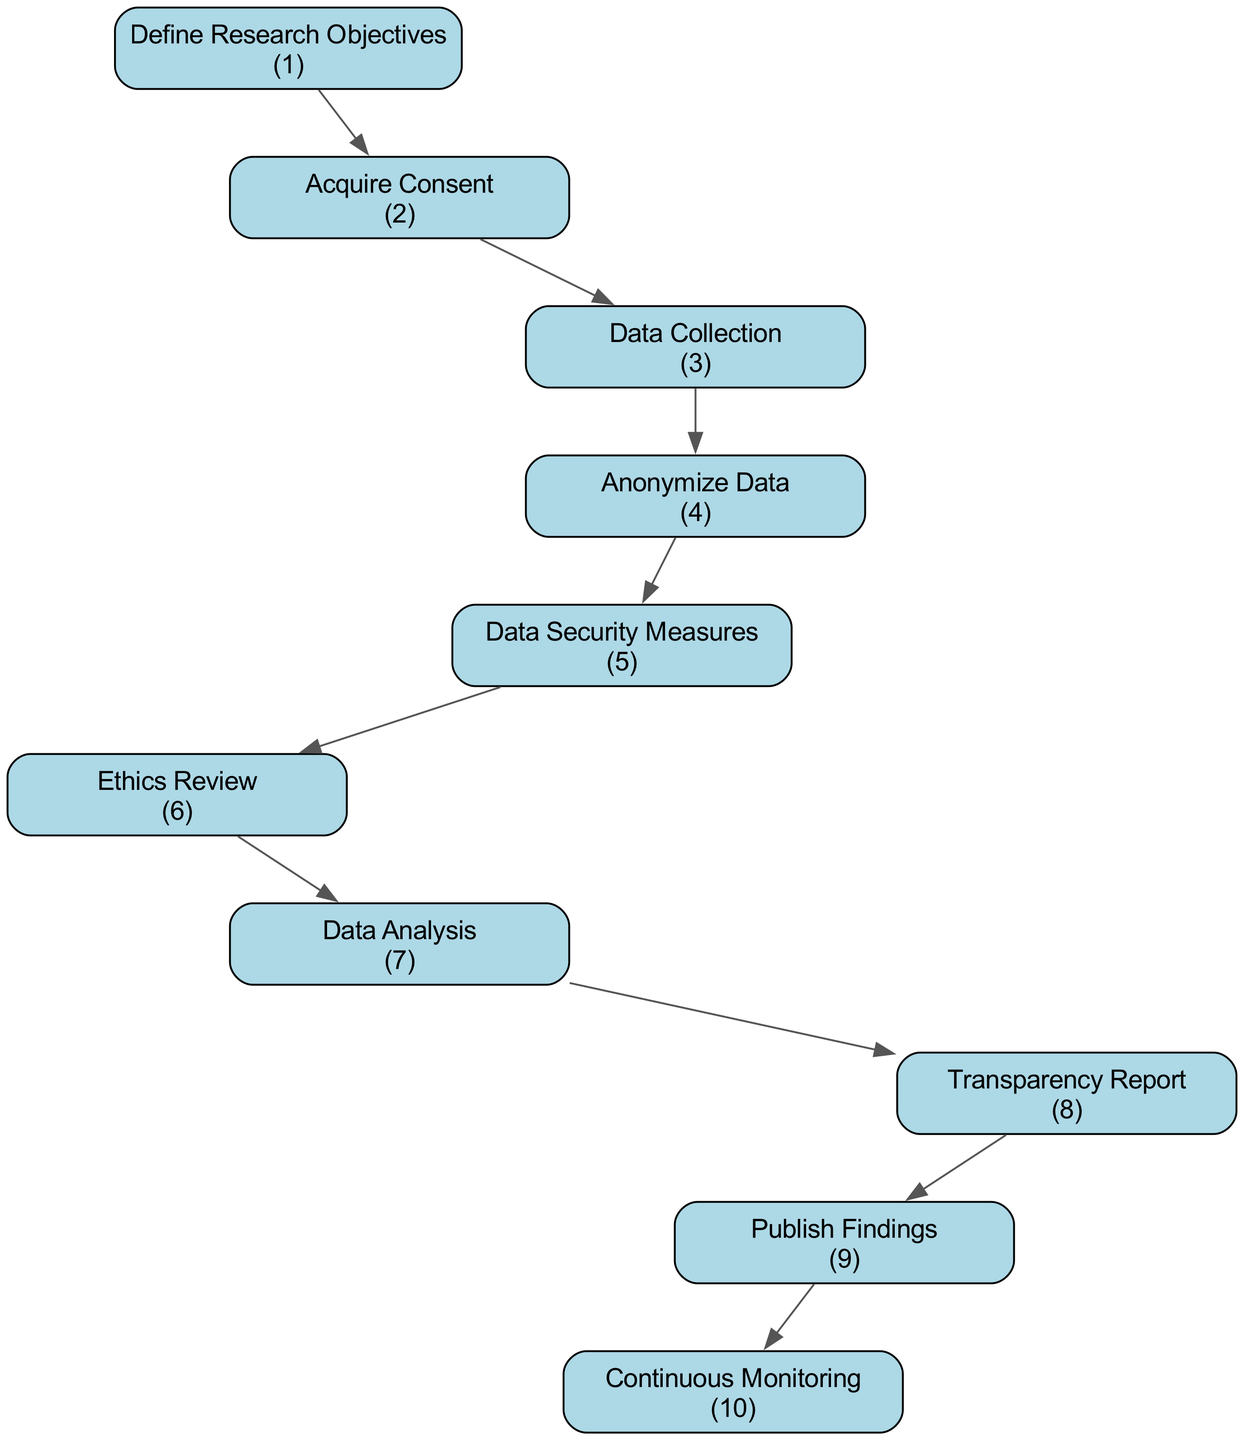What is the first step in the diagram? The first step is "Define Research Objectives," indicated as node 1 in the flow chart.
Answer: Define Research Objectives How many nodes are present in the diagram? By counting each distinct step, there are 10 nodes illustrated in the flow chart.
Answer: 10 What is the last step of the process? The last step, according to the flow of the diagram, is "Continuous Monitoring," which is referenced as node 10.
Answer: Continuous Monitoring Which step requires submission to an ethics committee? The "Ethics Review" step, identified as node 6, involves submitting plans to an ethics committee for approval.
Answer: Ethics Review How are participants' data handled before analysis? Data is anonymized by removing personally identifiable information and replacing it with unique codes, represented as step 4.
Answer: Anonymize Data What is the relationship between data collection and data analysis? "Data Collection" (step 3) precedes "Data Analysis" (step 7), indicating that data must be collected before it can be analyzed.
Answer: Data Collection → Data Analysis How many steps involve reports or findings? There are two steps in the diagram that involve reports or findings: "Transparency Report" (step 8) and "Publish Findings" (step 9).
Answer: 2 What follows the step involving obtaining consent? After "Acquire Consent" (step 2), the next step is "Data Collection" (step 3), showing the sequential flow of processes.
Answer: Data Collection What ensures compliance with evolving standards? "Continuous Monitoring," which is the last node (step 10), is the process that ensures regular review and updating of data practices for compliance.
Answer: Continuous Monitoring Which step comes after data security measures? Following "Data Security Measures" (step 5), the next step is "Ethics Review" (step 6) as per the flow of the diagram.
Answer: Ethics Review 